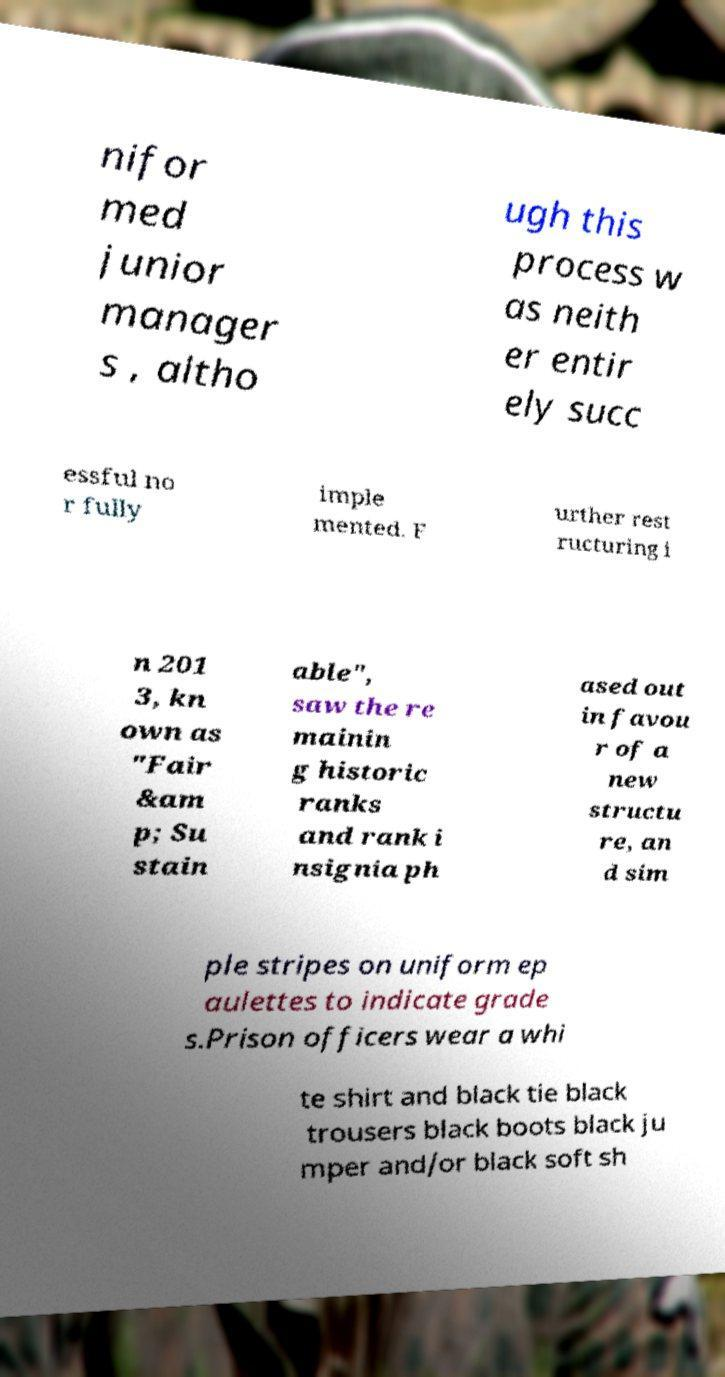Could you extract and type out the text from this image? nifor med junior manager s , altho ugh this process w as neith er entir ely succ essful no r fully imple mented. F urther rest ructuring i n 201 3, kn own as "Fair &am p; Su stain able", saw the re mainin g historic ranks and rank i nsignia ph ased out in favou r of a new structu re, an d sim ple stripes on uniform ep aulettes to indicate grade s.Prison officers wear a whi te shirt and black tie black trousers black boots black ju mper and/or black soft sh 